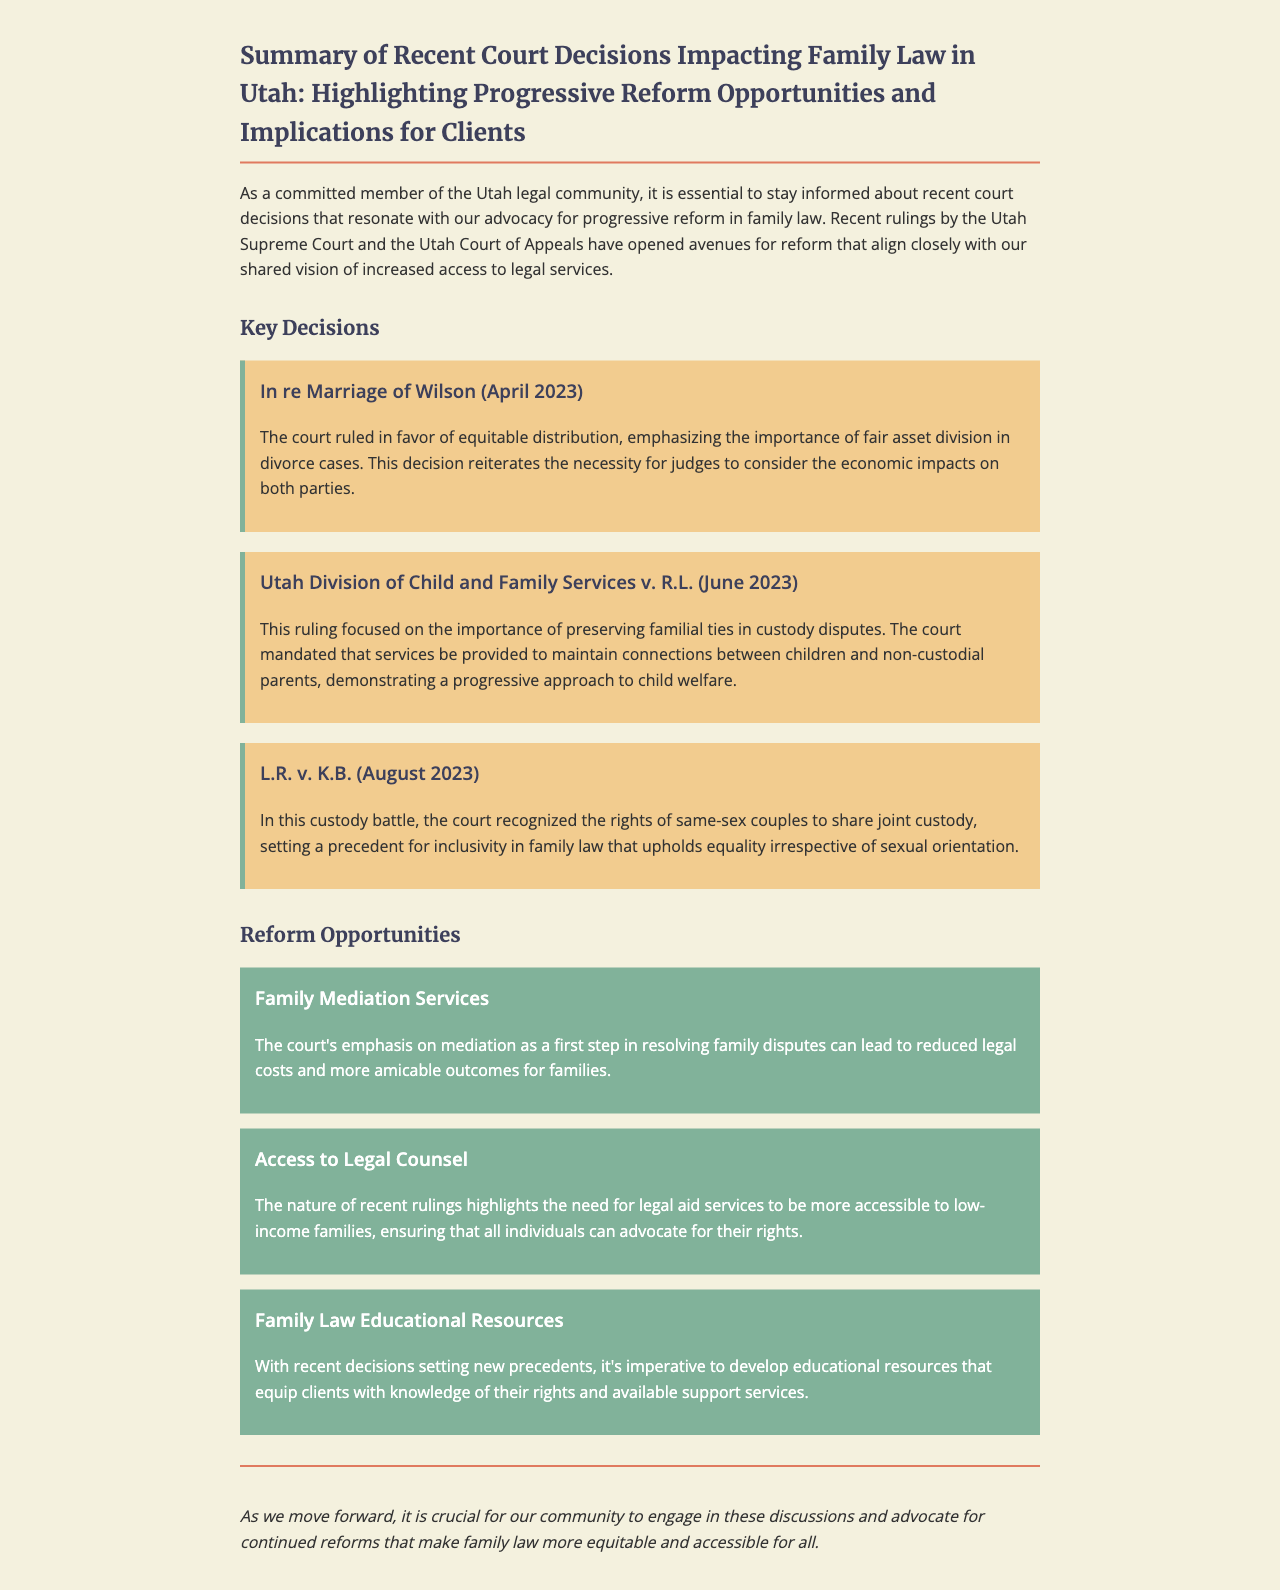What is the title of the document? The title clearly states the focus of the document, summarizing recent court decisions and their implications in family law.
Answer: Summary of Recent Court Decisions Impacting Family Law in Utah: Highlighting Progressive Reform Opportunities and Implications for Clients Which case emphasized equitable distribution in divorce? The document mentions a specific case that highlighted the importance of fair asset division in divorce proceedings.
Answer: In re Marriage of Wilson When did the ruling on preserving familial ties occur? The date of the court decision regarding custody disputes and familial ties is mentioned explicitly in the document.
Answer: June 2023 What progressive approach did the court take regarding non-custodial parents? The document discusses a ruling focused on maintaining connections between children and non-custodial parents in custody disputes.
Answer: Preserving familial ties What service does the document suggest to reduce legal costs in family disputes? The document highlights a specific approach that can lead to less expensive and amicable resolutions in family law.
Answer: Family Mediation Services What is the primary focus of the recent court rulings mentioned in the document? The document addresses the overall theme of these rulings and their implications for family law reform in Utah.
Answer: Progressive reform What opportunity for reform emphasizes accessible legal aid? The document underscores the need for legal services to be within reach for families facing financial challenges.
Answer: Access to Legal Counsel Which family law decision recognized same-sex couple rights? A specific custody case is stated in the document that set a precedent regarding joint custody for same-sex couples.
Answer: L.R. v. K.B 